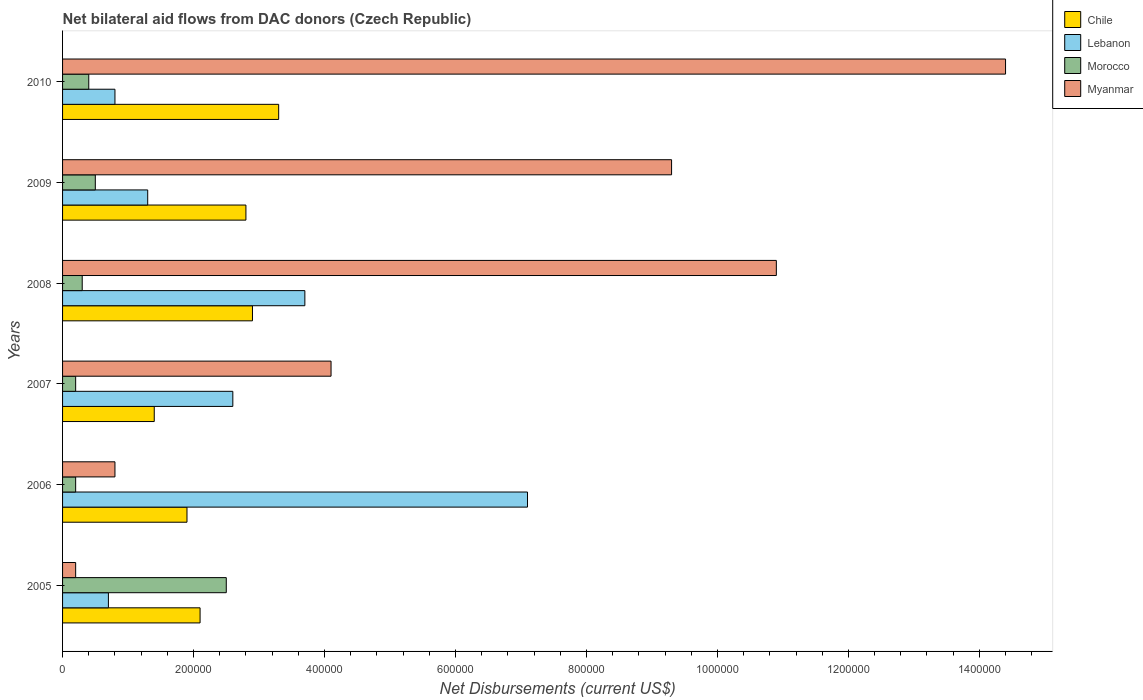How many groups of bars are there?
Your response must be concise. 6. How many bars are there on the 6th tick from the top?
Provide a short and direct response. 4. What is the label of the 4th group of bars from the top?
Keep it short and to the point. 2007. In how many cases, is the number of bars for a given year not equal to the number of legend labels?
Your answer should be very brief. 0. Across all years, what is the minimum net bilateral aid flows in Morocco?
Provide a short and direct response. 2.00e+04. In which year was the net bilateral aid flows in Myanmar maximum?
Offer a very short reply. 2010. In which year was the net bilateral aid flows in Lebanon minimum?
Ensure brevity in your answer.  2005. What is the difference between the net bilateral aid flows in Myanmar in 2008 and that in 2010?
Provide a short and direct response. -3.50e+05. What is the difference between the net bilateral aid flows in Morocco in 2010 and the net bilateral aid flows in Myanmar in 2009?
Provide a succinct answer. -8.90e+05. What is the average net bilateral aid flows in Morocco per year?
Your answer should be compact. 6.83e+04. In the year 2010, what is the difference between the net bilateral aid flows in Morocco and net bilateral aid flows in Myanmar?
Make the answer very short. -1.40e+06. In how many years, is the net bilateral aid flows in Morocco greater than 440000 US$?
Your answer should be compact. 0. Is the difference between the net bilateral aid flows in Morocco in 2006 and 2008 greater than the difference between the net bilateral aid flows in Myanmar in 2006 and 2008?
Your response must be concise. Yes. What is the difference between the highest and the second highest net bilateral aid flows in Lebanon?
Make the answer very short. 3.40e+05. What is the difference between the highest and the lowest net bilateral aid flows in Morocco?
Ensure brevity in your answer.  2.30e+05. In how many years, is the net bilateral aid flows in Myanmar greater than the average net bilateral aid flows in Myanmar taken over all years?
Keep it short and to the point. 3. What does the 2nd bar from the top in 2005 represents?
Provide a short and direct response. Morocco. What does the 2nd bar from the bottom in 2010 represents?
Your answer should be compact. Lebanon. How many bars are there?
Provide a short and direct response. 24. Are all the bars in the graph horizontal?
Offer a terse response. Yes. How many years are there in the graph?
Your answer should be compact. 6. Are the values on the major ticks of X-axis written in scientific E-notation?
Offer a terse response. No. Does the graph contain grids?
Your answer should be very brief. No. Where does the legend appear in the graph?
Keep it short and to the point. Top right. How many legend labels are there?
Provide a short and direct response. 4. How are the legend labels stacked?
Your answer should be very brief. Vertical. What is the title of the graph?
Your response must be concise. Net bilateral aid flows from DAC donors (Czech Republic). What is the label or title of the X-axis?
Give a very brief answer. Net Disbursements (current US$). What is the Net Disbursements (current US$) of Chile in 2005?
Your response must be concise. 2.10e+05. What is the Net Disbursements (current US$) of Lebanon in 2005?
Ensure brevity in your answer.  7.00e+04. What is the Net Disbursements (current US$) of Chile in 2006?
Make the answer very short. 1.90e+05. What is the Net Disbursements (current US$) in Lebanon in 2006?
Your answer should be compact. 7.10e+05. What is the Net Disbursements (current US$) in Morocco in 2006?
Provide a succinct answer. 2.00e+04. What is the Net Disbursements (current US$) in Lebanon in 2007?
Make the answer very short. 2.60e+05. What is the Net Disbursements (current US$) of Morocco in 2007?
Offer a terse response. 2.00e+04. What is the Net Disbursements (current US$) of Myanmar in 2007?
Keep it short and to the point. 4.10e+05. What is the Net Disbursements (current US$) in Myanmar in 2008?
Make the answer very short. 1.09e+06. What is the Net Disbursements (current US$) of Myanmar in 2009?
Ensure brevity in your answer.  9.30e+05. What is the Net Disbursements (current US$) in Myanmar in 2010?
Provide a short and direct response. 1.44e+06. Across all years, what is the maximum Net Disbursements (current US$) in Lebanon?
Make the answer very short. 7.10e+05. Across all years, what is the maximum Net Disbursements (current US$) of Myanmar?
Your answer should be very brief. 1.44e+06. Across all years, what is the minimum Net Disbursements (current US$) in Myanmar?
Offer a very short reply. 2.00e+04. What is the total Net Disbursements (current US$) in Chile in the graph?
Your response must be concise. 1.44e+06. What is the total Net Disbursements (current US$) in Lebanon in the graph?
Your answer should be very brief. 1.62e+06. What is the total Net Disbursements (current US$) of Myanmar in the graph?
Provide a short and direct response. 3.97e+06. What is the difference between the Net Disbursements (current US$) in Lebanon in 2005 and that in 2006?
Keep it short and to the point. -6.40e+05. What is the difference between the Net Disbursements (current US$) of Myanmar in 2005 and that in 2006?
Give a very brief answer. -6.00e+04. What is the difference between the Net Disbursements (current US$) of Chile in 2005 and that in 2007?
Your answer should be very brief. 7.00e+04. What is the difference between the Net Disbursements (current US$) in Lebanon in 2005 and that in 2007?
Make the answer very short. -1.90e+05. What is the difference between the Net Disbursements (current US$) of Myanmar in 2005 and that in 2007?
Provide a short and direct response. -3.90e+05. What is the difference between the Net Disbursements (current US$) in Myanmar in 2005 and that in 2008?
Give a very brief answer. -1.07e+06. What is the difference between the Net Disbursements (current US$) in Chile in 2005 and that in 2009?
Your answer should be compact. -7.00e+04. What is the difference between the Net Disbursements (current US$) of Morocco in 2005 and that in 2009?
Give a very brief answer. 2.00e+05. What is the difference between the Net Disbursements (current US$) of Myanmar in 2005 and that in 2009?
Keep it short and to the point. -9.10e+05. What is the difference between the Net Disbursements (current US$) of Lebanon in 2005 and that in 2010?
Keep it short and to the point. -10000. What is the difference between the Net Disbursements (current US$) of Myanmar in 2005 and that in 2010?
Your answer should be very brief. -1.42e+06. What is the difference between the Net Disbursements (current US$) in Chile in 2006 and that in 2007?
Offer a very short reply. 5.00e+04. What is the difference between the Net Disbursements (current US$) of Lebanon in 2006 and that in 2007?
Offer a very short reply. 4.50e+05. What is the difference between the Net Disbursements (current US$) in Myanmar in 2006 and that in 2007?
Provide a short and direct response. -3.30e+05. What is the difference between the Net Disbursements (current US$) in Lebanon in 2006 and that in 2008?
Offer a very short reply. 3.40e+05. What is the difference between the Net Disbursements (current US$) of Myanmar in 2006 and that in 2008?
Offer a terse response. -1.01e+06. What is the difference between the Net Disbursements (current US$) in Lebanon in 2006 and that in 2009?
Keep it short and to the point. 5.80e+05. What is the difference between the Net Disbursements (current US$) in Myanmar in 2006 and that in 2009?
Your response must be concise. -8.50e+05. What is the difference between the Net Disbursements (current US$) in Lebanon in 2006 and that in 2010?
Offer a very short reply. 6.30e+05. What is the difference between the Net Disbursements (current US$) of Myanmar in 2006 and that in 2010?
Provide a short and direct response. -1.36e+06. What is the difference between the Net Disbursements (current US$) of Lebanon in 2007 and that in 2008?
Ensure brevity in your answer.  -1.10e+05. What is the difference between the Net Disbursements (current US$) of Morocco in 2007 and that in 2008?
Your response must be concise. -10000. What is the difference between the Net Disbursements (current US$) of Myanmar in 2007 and that in 2008?
Offer a very short reply. -6.80e+05. What is the difference between the Net Disbursements (current US$) of Morocco in 2007 and that in 2009?
Provide a succinct answer. -3.00e+04. What is the difference between the Net Disbursements (current US$) of Myanmar in 2007 and that in 2009?
Provide a succinct answer. -5.20e+05. What is the difference between the Net Disbursements (current US$) of Chile in 2007 and that in 2010?
Your answer should be very brief. -1.90e+05. What is the difference between the Net Disbursements (current US$) of Lebanon in 2007 and that in 2010?
Provide a short and direct response. 1.80e+05. What is the difference between the Net Disbursements (current US$) in Myanmar in 2007 and that in 2010?
Offer a very short reply. -1.03e+06. What is the difference between the Net Disbursements (current US$) in Chile in 2008 and that in 2009?
Provide a short and direct response. 10000. What is the difference between the Net Disbursements (current US$) in Lebanon in 2008 and that in 2009?
Provide a succinct answer. 2.40e+05. What is the difference between the Net Disbursements (current US$) in Morocco in 2008 and that in 2010?
Ensure brevity in your answer.  -10000. What is the difference between the Net Disbursements (current US$) of Myanmar in 2008 and that in 2010?
Your response must be concise. -3.50e+05. What is the difference between the Net Disbursements (current US$) in Chile in 2009 and that in 2010?
Keep it short and to the point. -5.00e+04. What is the difference between the Net Disbursements (current US$) in Myanmar in 2009 and that in 2010?
Your answer should be very brief. -5.10e+05. What is the difference between the Net Disbursements (current US$) of Chile in 2005 and the Net Disbursements (current US$) of Lebanon in 2006?
Provide a short and direct response. -5.00e+05. What is the difference between the Net Disbursements (current US$) in Chile in 2005 and the Net Disbursements (current US$) in Morocco in 2006?
Offer a terse response. 1.90e+05. What is the difference between the Net Disbursements (current US$) of Lebanon in 2005 and the Net Disbursements (current US$) of Myanmar in 2006?
Offer a terse response. -10000. What is the difference between the Net Disbursements (current US$) in Morocco in 2005 and the Net Disbursements (current US$) in Myanmar in 2006?
Make the answer very short. 1.70e+05. What is the difference between the Net Disbursements (current US$) in Chile in 2005 and the Net Disbursements (current US$) in Lebanon in 2007?
Offer a very short reply. -5.00e+04. What is the difference between the Net Disbursements (current US$) in Lebanon in 2005 and the Net Disbursements (current US$) in Morocco in 2007?
Provide a succinct answer. 5.00e+04. What is the difference between the Net Disbursements (current US$) of Chile in 2005 and the Net Disbursements (current US$) of Morocco in 2008?
Your answer should be very brief. 1.80e+05. What is the difference between the Net Disbursements (current US$) in Chile in 2005 and the Net Disbursements (current US$) in Myanmar in 2008?
Provide a succinct answer. -8.80e+05. What is the difference between the Net Disbursements (current US$) in Lebanon in 2005 and the Net Disbursements (current US$) in Myanmar in 2008?
Provide a succinct answer. -1.02e+06. What is the difference between the Net Disbursements (current US$) in Morocco in 2005 and the Net Disbursements (current US$) in Myanmar in 2008?
Provide a succinct answer. -8.40e+05. What is the difference between the Net Disbursements (current US$) in Chile in 2005 and the Net Disbursements (current US$) in Morocco in 2009?
Ensure brevity in your answer.  1.60e+05. What is the difference between the Net Disbursements (current US$) of Chile in 2005 and the Net Disbursements (current US$) of Myanmar in 2009?
Offer a terse response. -7.20e+05. What is the difference between the Net Disbursements (current US$) of Lebanon in 2005 and the Net Disbursements (current US$) of Myanmar in 2009?
Your answer should be compact. -8.60e+05. What is the difference between the Net Disbursements (current US$) in Morocco in 2005 and the Net Disbursements (current US$) in Myanmar in 2009?
Your answer should be very brief. -6.80e+05. What is the difference between the Net Disbursements (current US$) in Chile in 2005 and the Net Disbursements (current US$) in Lebanon in 2010?
Your response must be concise. 1.30e+05. What is the difference between the Net Disbursements (current US$) of Chile in 2005 and the Net Disbursements (current US$) of Myanmar in 2010?
Keep it short and to the point. -1.23e+06. What is the difference between the Net Disbursements (current US$) in Lebanon in 2005 and the Net Disbursements (current US$) in Morocco in 2010?
Give a very brief answer. 3.00e+04. What is the difference between the Net Disbursements (current US$) in Lebanon in 2005 and the Net Disbursements (current US$) in Myanmar in 2010?
Give a very brief answer. -1.37e+06. What is the difference between the Net Disbursements (current US$) in Morocco in 2005 and the Net Disbursements (current US$) in Myanmar in 2010?
Make the answer very short. -1.19e+06. What is the difference between the Net Disbursements (current US$) of Chile in 2006 and the Net Disbursements (current US$) of Lebanon in 2007?
Provide a succinct answer. -7.00e+04. What is the difference between the Net Disbursements (current US$) in Chile in 2006 and the Net Disbursements (current US$) in Morocco in 2007?
Your response must be concise. 1.70e+05. What is the difference between the Net Disbursements (current US$) of Chile in 2006 and the Net Disbursements (current US$) of Myanmar in 2007?
Offer a terse response. -2.20e+05. What is the difference between the Net Disbursements (current US$) of Lebanon in 2006 and the Net Disbursements (current US$) of Morocco in 2007?
Keep it short and to the point. 6.90e+05. What is the difference between the Net Disbursements (current US$) in Morocco in 2006 and the Net Disbursements (current US$) in Myanmar in 2007?
Give a very brief answer. -3.90e+05. What is the difference between the Net Disbursements (current US$) of Chile in 2006 and the Net Disbursements (current US$) of Myanmar in 2008?
Keep it short and to the point. -9.00e+05. What is the difference between the Net Disbursements (current US$) of Lebanon in 2006 and the Net Disbursements (current US$) of Morocco in 2008?
Your response must be concise. 6.80e+05. What is the difference between the Net Disbursements (current US$) of Lebanon in 2006 and the Net Disbursements (current US$) of Myanmar in 2008?
Ensure brevity in your answer.  -3.80e+05. What is the difference between the Net Disbursements (current US$) in Morocco in 2006 and the Net Disbursements (current US$) in Myanmar in 2008?
Your response must be concise. -1.07e+06. What is the difference between the Net Disbursements (current US$) of Chile in 2006 and the Net Disbursements (current US$) of Lebanon in 2009?
Give a very brief answer. 6.00e+04. What is the difference between the Net Disbursements (current US$) in Chile in 2006 and the Net Disbursements (current US$) in Myanmar in 2009?
Provide a short and direct response. -7.40e+05. What is the difference between the Net Disbursements (current US$) of Morocco in 2006 and the Net Disbursements (current US$) of Myanmar in 2009?
Your response must be concise. -9.10e+05. What is the difference between the Net Disbursements (current US$) in Chile in 2006 and the Net Disbursements (current US$) in Myanmar in 2010?
Offer a terse response. -1.25e+06. What is the difference between the Net Disbursements (current US$) in Lebanon in 2006 and the Net Disbursements (current US$) in Morocco in 2010?
Offer a terse response. 6.70e+05. What is the difference between the Net Disbursements (current US$) in Lebanon in 2006 and the Net Disbursements (current US$) in Myanmar in 2010?
Ensure brevity in your answer.  -7.30e+05. What is the difference between the Net Disbursements (current US$) in Morocco in 2006 and the Net Disbursements (current US$) in Myanmar in 2010?
Your answer should be compact. -1.42e+06. What is the difference between the Net Disbursements (current US$) in Chile in 2007 and the Net Disbursements (current US$) in Lebanon in 2008?
Your response must be concise. -2.30e+05. What is the difference between the Net Disbursements (current US$) of Chile in 2007 and the Net Disbursements (current US$) of Myanmar in 2008?
Ensure brevity in your answer.  -9.50e+05. What is the difference between the Net Disbursements (current US$) of Lebanon in 2007 and the Net Disbursements (current US$) of Myanmar in 2008?
Your answer should be very brief. -8.30e+05. What is the difference between the Net Disbursements (current US$) in Morocco in 2007 and the Net Disbursements (current US$) in Myanmar in 2008?
Your response must be concise. -1.07e+06. What is the difference between the Net Disbursements (current US$) in Chile in 2007 and the Net Disbursements (current US$) in Lebanon in 2009?
Provide a succinct answer. 10000. What is the difference between the Net Disbursements (current US$) of Chile in 2007 and the Net Disbursements (current US$) of Morocco in 2009?
Offer a very short reply. 9.00e+04. What is the difference between the Net Disbursements (current US$) of Chile in 2007 and the Net Disbursements (current US$) of Myanmar in 2009?
Your response must be concise. -7.90e+05. What is the difference between the Net Disbursements (current US$) in Lebanon in 2007 and the Net Disbursements (current US$) in Myanmar in 2009?
Your answer should be compact. -6.70e+05. What is the difference between the Net Disbursements (current US$) in Morocco in 2007 and the Net Disbursements (current US$) in Myanmar in 2009?
Your answer should be compact. -9.10e+05. What is the difference between the Net Disbursements (current US$) of Chile in 2007 and the Net Disbursements (current US$) of Lebanon in 2010?
Your answer should be compact. 6.00e+04. What is the difference between the Net Disbursements (current US$) of Chile in 2007 and the Net Disbursements (current US$) of Myanmar in 2010?
Ensure brevity in your answer.  -1.30e+06. What is the difference between the Net Disbursements (current US$) in Lebanon in 2007 and the Net Disbursements (current US$) in Morocco in 2010?
Give a very brief answer. 2.20e+05. What is the difference between the Net Disbursements (current US$) of Lebanon in 2007 and the Net Disbursements (current US$) of Myanmar in 2010?
Your answer should be compact. -1.18e+06. What is the difference between the Net Disbursements (current US$) of Morocco in 2007 and the Net Disbursements (current US$) of Myanmar in 2010?
Your response must be concise. -1.42e+06. What is the difference between the Net Disbursements (current US$) in Chile in 2008 and the Net Disbursements (current US$) in Morocco in 2009?
Keep it short and to the point. 2.40e+05. What is the difference between the Net Disbursements (current US$) of Chile in 2008 and the Net Disbursements (current US$) of Myanmar in 2009?
Provide a succinct answer. -6.40e+05. What is the difference between the Net Disbursements (current US$) of Lebanon in 2008 and the Net Disbursements (current US$) of Myanmar in 2009?
Your response must be concise. -5.60e+05. What is the difference between the Net Disbursements (current US$) in Morocco in 2008 and the Net Disbursements (current US$) in Myanmar in 2009?
Provide a short and direct response. -9.00e+05. What is the difference between the Net Disbursements (current US$) in Chile in 2008 and the Net Disbursements (current US$) in Myanmar in 2010?
Provide a succinct answer. -1.15e+06. What is the difference between the Net Disbursements (current US$) in Lebanon in 2008 and the Net Disbursements (current US$) in Myanmar in 2010?
Make the answer very short. -1.07e+06. What is the difference between the Net Disbursements (current US$) in Morocco in 2008 and the Net Disbursements (current US$) in Myanmar in 2010?
Offer a terse response. -1.41e+06. What is the difference between the Net Disbursements (current US$) of Chile in 2009 and the Net Disbursements (current US$) of Lebanon in 2010?
Give a very brief answer. 2.00e+05. What is the difference between the Net Disbursements (current US$) in Chile in 2009 and the Net Disbursements (current US$) in Morocco in 2010?
Ensure brevity in your answer.  2.40e+05. What is the difference between the Net Disbursements (current US$) in Chile in 2009 and the Net Disbursements (current US$) in Myanmar in 2010?
Give a very brief answer. -1.16e+06. What is the difference between the Net Disbursements (current US$) of Lebanon in 2009 and the Net Disbursements (current US$) of Myanmar in 2010?
Ensure brevity in your answer.  -1.31e+06. What is the difference between the Net Disbursements (current US$) of Morocco in 2009 and the Net Disbursements (current US$) of Myanmar in 2010?
Provide a succinct answer. -1.39e+06. What is the average Net Disbursements (current US$) in Lebanon per year?
Ensure brevity in your answer.  2.70e+05. What is the average Net Disbursements (current US$) in Morocco per year?
Provide a succinct answer. 6.83e+04. What is the average Net Disbursements (current US$) in Myanmar per year?
Give a very brief answer. 6.62e+05. In the year 2005, what is the difference between the Net Disbursements (current US$) in Chile and Net Disbursements (current US$) in Morocco?
Provide a succinct answer. -4.00e+04. In the year 2005, what is the difference between the Net Disbursements (current US$) in Chile and Net Disbursements (current US$) in Myanmar?
Make the answer very short. 1.90e+05. In the year 2005, what is the difference between the Net Disbursements (current US$) of Lebanon and Net Disbursements (current US$) of Morocco?
Provide a short and direct response. -1.80e+05. In the year 2005, what is the difference between the Net Disbursements (current US$) of Lebanon and Net Disbursements (current US$) of Myanmar?
Your answer should be compact. 5.00e+04. In the year 2006, what is the difference between the Net Disbursements (current US$) of Chile and Net Disbursements (current US$) of Lebanon?
Your answer should be compact. -5.20e+05. In the year 2006, what is the difference between the Net Disbursements (current US$) of Chile and Net Disbursements (current US$) of Morocco?
Provide a succinct answer. 1.70e+05. In the year 2006, what is the difference between the Net Disbursements (current US$) of Lebanon and Net Disbursements (current US$) of Morocco?
Ensure brevity in your answer.  6.90e+05. In the year 2006, what is the difference between the Net Disbursements (current US$) of Lebanon and Net Disbursements (current US$) of Myanmar?
Ensure brevity in your answer.  6.30e+05. In the year 2007, what is the difference between the Net Disbursements (current US$) in Chile and Net Disbursements (current US$) in Lebanon?
Provide a short and direct response. -1.20e+05. In the year 2007, what is the difference between the Net Disbursements (current US$) in Chile and Net Disbursements (current US$) in Morocco?
Your answer should be very brief. 1.20e+05. In the year 2007, what is the difference between the Net Disbursements (current US$) of Morocco and Net Disbursements (current US$) of Myanmar?
Keep it short and to the point. -3.90e+05. In the year 2008, what is the difference between the Net Disbursements (current US$) of Chile and Net Disbursements (current US$) of Myanmar?
Your response must be concise. -8.00e+05. In the year 2008, what is the difference between the Net Disbursements (current US$) of Lebanon and Net Disbursements (current US$) of Morocco?
Your answer should be very brief. 3.40e+05. In the year 2008, what is the difference between the Net Disbursements (current US$) in Lebanon and Net Disbursements (current US$) in Myanmar?
Ensure brevity in your answer.  -7.20e+05. In the year 2008, what is the difference between the Net Disbursements (current US$) of Morocco and Net Disbursements (current US$) of Myanmar?
Keep it short and to the point. -1.06e+06. In the year 2009, what is the difference between the Net Disbursements (current US$) in Chile and Net Disbursements (current US$) in Lebanon?
Offer a very short reply. 1.50e+05. In the year 2009, what is the difference between the Net Disbursements (current US$) in Chile and Net Disbursements (current US$) in Morocco?
Offer a very short reply. 2.30e+05. In the year 2009, what is the difference between the Net Disbursements (current US$) in Chile and Net Disbursements (current US$) in Myanmar?
Make the answer very short. -6.50e+05. In the year 2009, what is the difference between the Net Disbursements (current US$) of Lebanon and Net Disbursements (current US$) of Morocco?
Your answer should be compact. 8.00e+04. In the year 2009, what is the difference between the Net Disbursements (current US$) in Lebanon and Net Disbursements (current US$) in Myanmar?
Your answer should be compact. -8.00e+05. In the year 2009, what is the difference between the Net Disbursements (current US$) in Morocco and Net Disbursements (current US$) in Myanmar?
Provide a succinct answer. -8.80e+05. In the year 2010, what is the difference between the Net Disbursements (current US$) of Chile and Net Disbursements (current US$) of Myanmar?
Offer a terse response. -1.11e+06. In the year 2010, what is the difference between the Net Disbursements (current US$) of Lebanon and Net Disbursements (current US$) of Myanmar?
Offer a terse response. -1.36e+06. In the year 2010, what is the difference between the Net Disbursements (current US$) in Morocco and Net Disbursements (current US$) in Myanmar?
Keep it short and to the point. -1.40e+06. What is the ratio of the Net Disbursements (current US$) of Chile in 2005 to that in 2006?
Ensure brevity in your answer.  1.11. What is the ratio of the Net Disbursements (current US$) in Lebanon in 2005 to that in 2006?
Give a very brief answer. 0.1. What is the ratio of the Net Disbursements (current US$) in Myanmar in 2005 to that in 2006?
Offer a very short reply. 0.25. What is the ratio of the Net Disbursements (current US$) of Lebanon in 2005 to that in 2007?
Give a very brief answer. 0.27. What is the ratio of the Net Disbursements (current US$) of Morocco in 2005 to that in 2007?
Provide a short and direct response. 12.5. What is the ratio of the Net Disbursements (current US$) of Myanmar in 2005 to that in 2007?
Make the answer very short. 0.05. What is the ratio of the Net Disbursements (current US$) in Chile in 2005 to that in 2008?
Give a very brief answer. 0.72. What is the ratio of the Net Disbursements (current US$) of Lebanon in 2005 to that in 2008?
Give a very brief answer. 0.19. What is the ratio of the Net Disbursements (current US$) in Morocco in 2005 to that in 2008?
Your answer should be very brief. 8.33. What is the ratio of the Net Disbursements (current US$) of Myanmar in 2005 to that in 2008?
Your answer should be compact. 0.02. What is the ratio of the Net Disbursements (current US$) of Chile in 2005 to that in 2009?
Your answer should be very brief. 0.75. What is the ratio of the Net Disbursements (current US$) of Lebanon in 2005 to that in 2009?
Offer a very short reply. 0.54. What is the ratio of the Net Disbursements (current US$) of Myanmar in 2005 to that in 2009?
Ensure brevity in your answer.  0.02. What is the ratio of the Net Disbursements (current US$) in Chile in 2005 to that in 2010?
Provide a short and direct response. 0.64. What is the ratio of the Net Disbursements (current US$) of Morocco in 2005 to that in 2010?
Provide a succinct answer. 6.25. What is the ratio of the Net Disbursements (current US$) of Myanmar in 2005 to that in 2010?
Provide a succinct answer. 0.01. What is the ratio of the Net Disbursements (current US$) of Chile in 2006 to that in 2007?
Ensure brevity in your answer.  1.36. What is the ratio of the Net Disbursements (current US$) of Lebanon in 2006 to that in 2007?
Offer a very short reply. 2.73. What is the ratio of the Net Disbursements (current US$) of Myanmar in 2006 to that in 2007?
Your answer should be very brief. 0.2. What is the ratio of the Net Disbursements (current US$) of Chile in 2006 to that in 2008?
Make the answer very short. 0.66. What is the ratio of the Net Disbursements (current US$) of Lebanon in 2006 to that in 2008?
Give a very brief answer. 1.92. What is the ratio of the Net Disbursements (current US$) in Morocco in 2006 to that in 2008?
Make the answer very short. 0.67. What is the ratio of the Net Disbursements (current US$) of Myanmar in 2006 to that in 2008?
Provide a succinct answer. 0.07. What is the ratio of the Net Disbursements (current US$) of Chile in 2006 to that in 2009?
Ensure brevity in your answer.  0.68. What is the ratio of the Net Disbursements (current US$) in Lebanon in 2006 to that in 2009?
Offer a terse response. 5.46. What is the ratio of the Net Disbursements (current US$) of Morocco in 2006 to that in 2009?
Offer a very short reply. 0.4. What is the ratio of the Net Disbursements (current US$) of Myanmar in 2006 to that in 2009?
Offer a terse response. 0.09. What is the ratio of the Net Disbursements (current US$) in Chile in 2006 to that in 2010?
Your answer should be very brief. 0.58. What is the ratio of the Net Disbursements (current US$) of Lebanon in 2006 to that in 2010?
Give a very brief answer. 8.88. What is the ratio of the Net Disbursements (current US$) of Myanmar in 2006 to that in 2010?
Offer a very short reply. 0.06. What is the ratio of the Net Disbursements (current US$) in Chile in 2007 to that in 2008?
Provide a succinct answer. 0.48. What is the ratio of the Net Disbursements (current US$) in Lebanon in 2007 to that in 2008?
Offer a terse response. 0.7. What is the ratio of the Net Disbursements (current US$) of Myanmar in 2007 to that in 2008?
Your response must be concise. 0.38. What is the ratio of the Net Disbursements (current US$) in Myanmar in 2007 to that in 2009?
Offer a very short reply. 0.44. What is the ratio of the Net Disbursements (current US$) in Chile in 2007 to that in 2010?
Your response must be concise. 0.42. What is the ratio of the Net Disbursements (current US$) of Lebanon in 2007 to that in 2010?
Give a very brief answer. 3.25. What is the ratio of the Net Disbursements (current US$) of Myanmar in 2007 to that in 2010?
Ensure brevity in your answer.  0.28. What is the ratio of the Net Disbursements (current US$) in Chile in 2008 to that in 2009?
Provide a succinct answer. 1.04. What is the ratio of the Net Disbursements (current US$) in Lebanon in 2008 to that in 2009?
Offer a terse response. 2.85. What is the ratio of the Net Disbursements (current US$) in Morocco in 2008 to that in 2009?
Your answer should be very brief. 0.6. What is the ratio of the Net Disbursements (current US$) in Myanmar in 2008 to that in 2009?
Your response must be concise. 1.17. What is the ratio of the Net Disbursements (current US$) of Chile in 2008 to that in 2010?
Give a very brief answer. 0.88. What is the ratio of the Net Disbursements (current US$) in Lebanon in 2008 to that in 2010?
Provide a short and direct response. 4.62. What is the ratio of the Net Disbursements (current US$) of Myanmar in 2008 to that in 2010?
Your answer should be compact. 0.76. What is the ratio of the Net Disbursements (current US$) in Chile in 2009 to that in 2010?
Keep it short and to the point. 0.85. What is the ratio of the Net Disbursements (current US$) of Lebanon in 2009 to that in 2010?
Give a very brief answer. 1.62. What is the ratio of the Net Disbursements (current US$) of Morocco in 2009 to that in 2010?
Keep it short and to the point. 1.25. What is the ratio of the Net Disbursements (current US$) in Myanmar in 2009 to that in 2010?
Give a very brief answer. 0.65. What is the difference between the highest and the second highest Net Disbursements (current US$) of Chile?
Keep it short and to the point. 4.00e+04. What is the difference between the highest and the second highest Net Disbursements (current US$) in Lebanon?
Give a very brief answer. 3.40e+05. What is the difference between the highest and the second highest Net Disbursements (current US$) of Myanmar?
Provide a succinct answer. 3.50e+05. What is the difference between the highest and the lowest Net Disbursements (current US$) of Lebanon?
Your answer should be very brief. 6.40e+05. What is the difference between the highest and the lowest Net Disbursements (current US$) of Morocco?
Provide a succinct answer. 2.30e+05. What is the difference between the highest and the lowest Net Disbursements (current US$) of Myanmar?
Offer a terse response. 1.42e+06. 